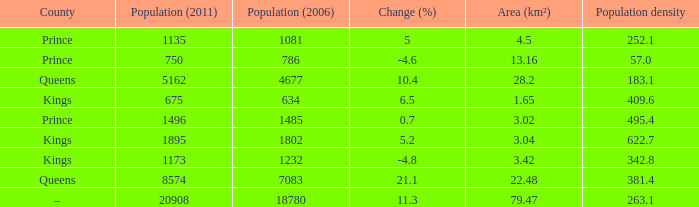What was the Population (2011) when the Population (2006) was less than 7083, and the Population density less than 342.8, and the Change (%) of 5, and an Area (km²) larger than 4.5? 0.0. 